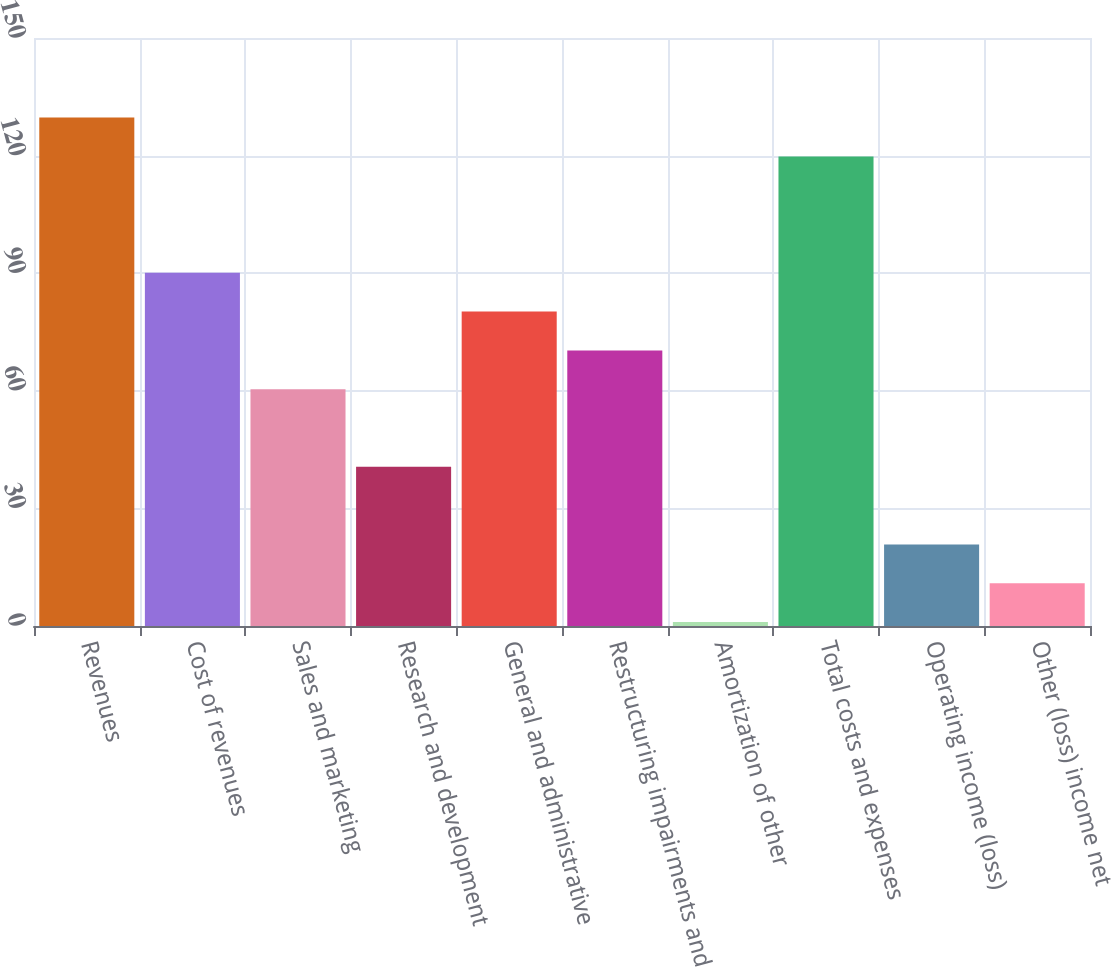Convert chart. <chart><loc_0><loc_0><loc_500><loc_500><bar_chart><fcel>Revenues<fcel>Cost of revenues<fcel>Sales and marketing<fcel>Research and development<fcel>General and administrative<fcel>Restructuring impairments and<fcel>Amortization of other<fcel>Total costs and expenses<fcel>Operating income (loss)<fcel>Other (loss) income net<nl><fcel>129.7<fcel>90.1<fcel>60.4<fcel>40.6<fcel>80.2<fcel>70.3<fcel>1<fcel>119.8<fcel>20.8<fcel>10.9<nl></chart> 